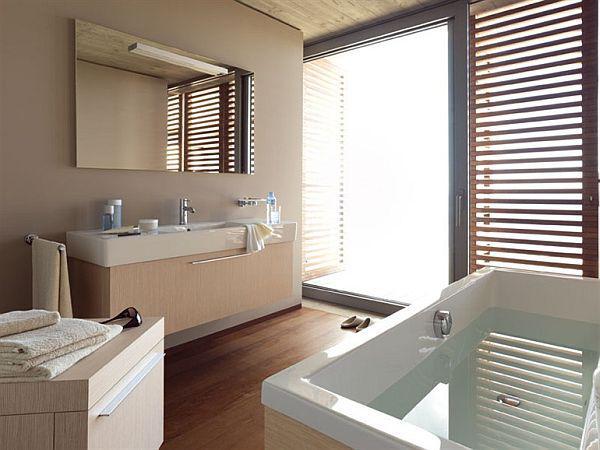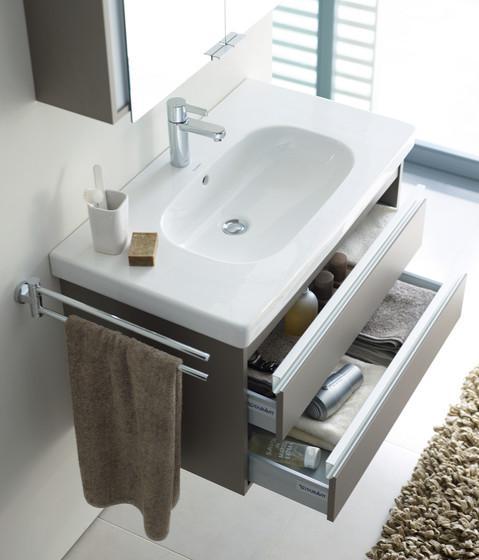The first image is the image on the left, the second image is the image on the right. Examine the images to the left and right. Is the description "There are two open drawers visible." accurate? Answer yes or no. Yes. The first image is the image on the left, the second image is the image on the right. Analyze the images presented: Is the assertion "The bathroom on the left features a freestanding bathtub and a wide rectangular mirror over the sink vanity, and the right image shows a towel on a chrome bar alongside the vanity." valid? Answer yes or no. Yes. 